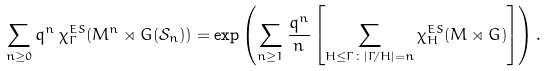<formula> <loc_0><loc_0><loc_500><loc_500>\sum _ { n \geq 0 } q ^ { n } \, \chi ^ { E S } _ { \Gamma } ( M ^ { n } \rtimes G ( { \mathcal { S } } _ { n } ) ) = \exp \left ( \sum _ { n \geq 1 } \frac { q ^ { n } } n \left [ \sum _ { H \leq \Gamma \colon | \Gamma / H | = n } \chi ^ { E S } _ { H } ( M \rtimes G ) \right ] \right ) .</formula> 